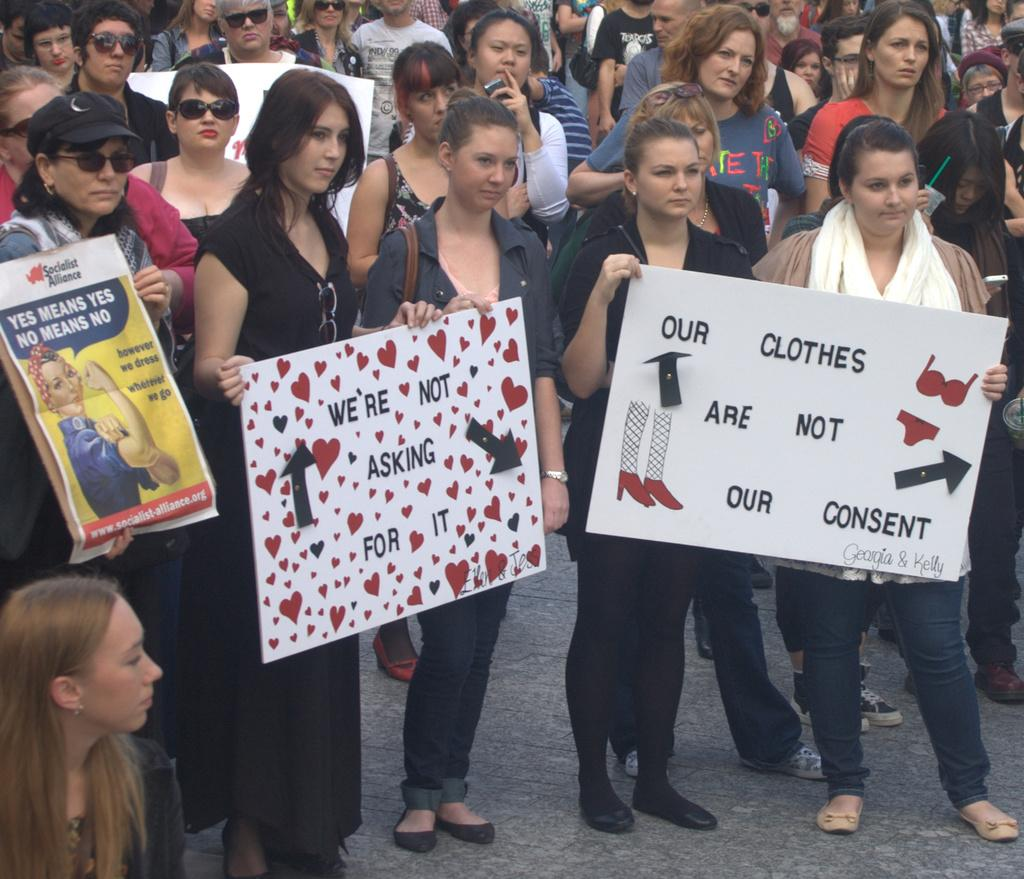How many people are in the group shown in the image? There is a group of people in the image, but the exact number is not specified. What are some of the people in the group holding? Some people in the group are holding objects, but the specific objects are not mentioned. What can be seen at the bottom of the image? There is a path visible at the bottom of the image. How does the group of people plan to increase their love for each other in the image? There is no indication in the image that the group of people is trying to increase their love for each other. 